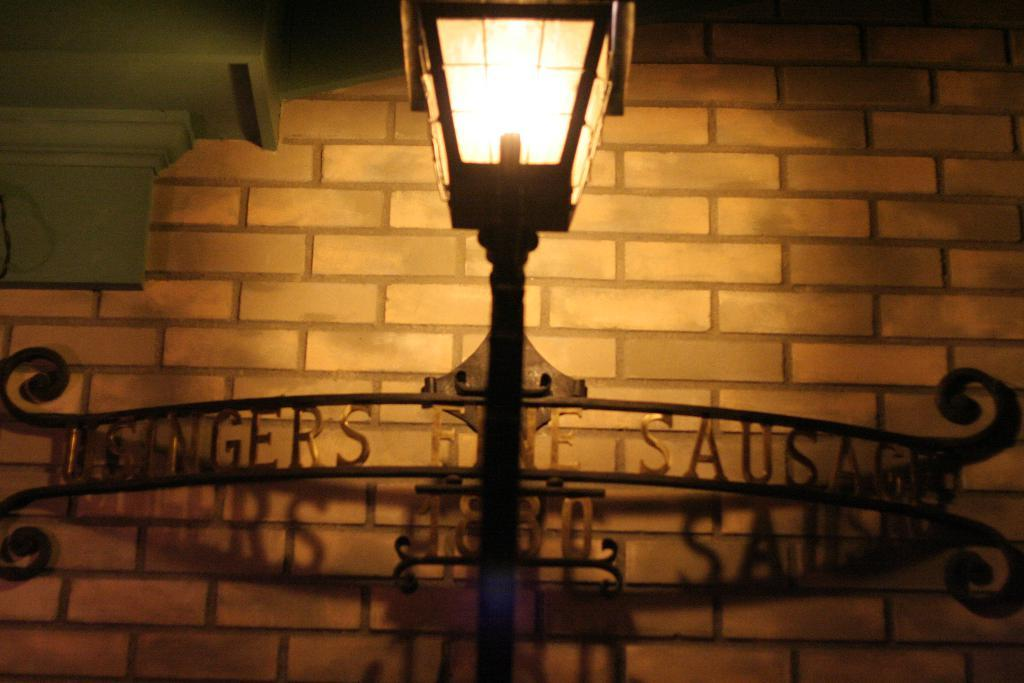What is the main object in the center of the image? There is a lamp post in the center of the image. What can be seen in the background of the image? There is a brick wall in the background of the image. What type of objects are attached to the brick wall? There are metal objects with text attached to them in the background of the image. What type of cake is being served at the event in the image? There is no event or cake present in the image; it features a lamp post and a brick wall with metal objects. How does the person in the image hear the music without any visible speakers? There is no person or music present in the image; it only shows a lamp post and a brick wall with metal objects. 